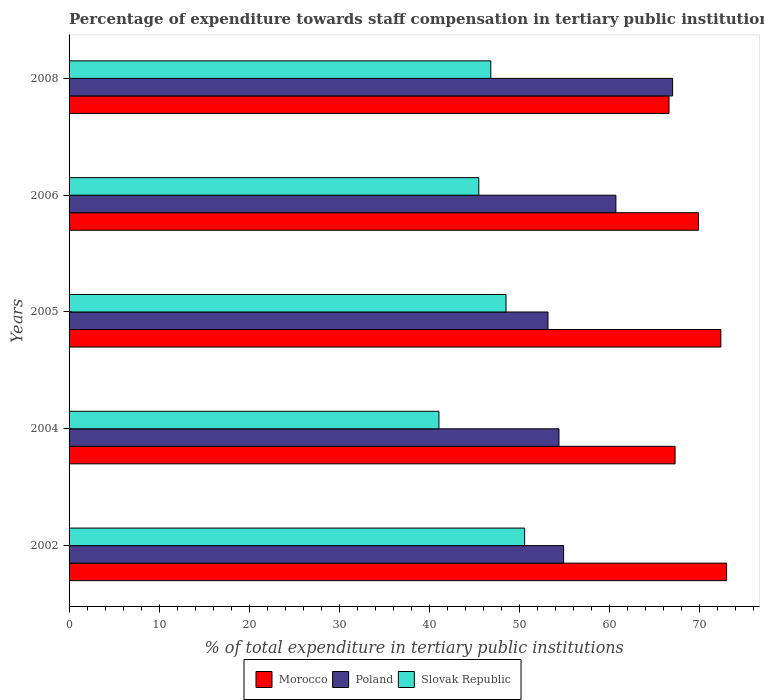How many different coloured bars are there?
Make the answer very short. 3. Are the number of bars per tick equal to the number of legend labels?
Keep it short and to the point. Yes. Are the number of bars on each tick of the Y-axis equal?
Your answer should be very brief. Yes. In how many cases, is the number of bars for a given year not equal to the number of legend labels?
Ensure brevity in your answer.  0. What is the percentage of expenditure towards staff compensation in Poland in 2004?
Your response must be concise. 54.37. Across all years, what is the maximum percentage of expenditure towards staff compensation in Slovak Republic?
Offer a very short reply. 50.56. Across all years, what is the minimum percentage of expenditure towards staff compensation in Poland?
Provide a succinct answer. 53.15. In which year was the percentage of expenditure towards staff compensation in Poland maximum?
Your answer should be compact. 2008. What is the total percentage of expenditure towards staff compensation in Slovak Republic in the graph?
Your answer should be very brief. 232.39. What is the difference between the percentage of expenditure towards staff compensation in Morocco in 2004 and that in 2006?
Your answer should be very brief. -2.59. What is the difference between the percentage of expenditure towards staff compensation in Morocco in 2006 and the percentage of expenditure towards staff compensation in Slovak Republic in 2002?
Provide a short and direct response. 19.29. What is the average percentage of expenditure towards staff compensation in Slovak Republic per year?
Your response must be concise. 46.48. In the year 2002, what is the difference between the percentage of expenditure towards staff compensation in Slovak Republic and percentage of expenditure towards staff compensation in Morocco?
Ensure brevity in your answer.  -22.42. In how many years, is the percentage of expenditure towards staff compensation in Poland greater than 20 %?
Your answer should be compact. 5. What is the ratio of the percentage of expenditure towards staff compensation in Morocco in 2005 to that in 2008?
Offer a terse response. 1.09. What is the difference between the highest and the second highest percentage of expenditure towards staff compensation in Morocco?
Ensure brevity in your answer.  0.64. What is the difference between the highest and the lowest percentage of expenditure towards staff compensation in Poland?
Provide a succinct answer. 13.83. What does the 1st bar from the top in 2002 represents?
Offer a terse response. Slovak Republic. How many years are there in the graph?
Make the answer very short. 5. What is the difference between two consecutive major ticks on the X-axis?
Offer a terse response. 10. Does the graph contain any zero values?
Your answer should be compact. No. Does the graph contain grids?
Keep it short and to the point. No. How are the legend labels stacked?
Your response must be concise. Horizontal. What is the title of the graph?
Keep it short and to the point. Percentage of expenditure towards staff compensation in tertiary public institutions. Does "Kyrgyz Republic" appear as one of the legend labels in the graph?
Offer a very short reply. No. What is the label or title of the X-axis?
Give a very brief answer. % of total expenditure in tertiary public institutions. What is the % of total expenditure in tertiary public institutions of Morocco in 2002?
Ensure brevity in your answer.  72.98. What is the % of total expenditure in tertiary public institutions of Poland in 2002?
Keep it short and to the point. 54.89. What is the % of total expenditure in tertiary public institutions in Slovak Republic in 2002?
Offer a terse response. 50.56. What is the % of total expenditure in tertiary public institutions in Morocco in 2004?
Give a very brief answer. 67.26. What is the % of total expenditure in tertiary public institutions in Poland in 2004?
Your answer should be compact. 54.37. What is the % of total expenditure in tertiary public institutions of Slovak Republic in 2004?
Your answer should be very brief. 41.05. What is the % of total expenditure in tertiary public institutions in Morocco in 2005?
Keep it short and to the point. 72.34. What is the % of total expenditure in tertiary public institutions in Poland in 2005?
Keep it short and to the point. 53.15. What is the % of total expenditure in tertiary public institutions in Slovak Republic in 2005?
Ensure brevity in your answer.  48.5. What is the % of total expenditure in tertiary public institutions of Morocco in 2006?
Your answer should be compact. 69.85. What is the % of total expenditure in tertiary public institutions in Poland in 2006?
Give a very brief answer. 60.69. What is the % of total expenditure in tertiary public institutions in Slovak Republic in 2006?
Your answer should be very brief. 45.47. What is the % of total expenditure in tertiary public institutions in Morocco in 2008?
Keep it short and to the point. 66.59. What is the % of total expenditure in tertiary public institutions of Poland in 2008?
Provide a short and direct response. 66.99. What is the % of total expenditure in tertiary public institutions of Slovak Republic in 2008?
Make the answer very short. 46.81. Across all years, what is the maximum % of total expenditure in tertiary public institutions of Morocco?
Ensure brevity in your answer.  72.98. Across all years, what is the maximum % of total expenditure in tertiary public institutions in Poland?
Provide a short and direct response. 66.99. Across all years, what is the maximum % of total expenditure in tertiary public institutions in Slovak Republic?
Offer a very short reply. 50.56. Across all years, what is the minimum % of total expenditure in tertiary public institutions in Morocco?
Offer a very short reply. 66.59. Across all years, what is the minimum % of total expenditure in tertiary public institutions in Poland?
Make the answer very short. 53.15. Across all years, what is the minimum % of total expenditure in tertiary public institutions of Slovak Republic?
Ensure brevity in your answer.  41.05. What is the total % of total expenditure in tertiary public institutions in Morocco in the graph?
Keep it short and to the point. 349.01. What is the total % of total expenditure in tertiary public institutions in Poland in the graph?
Your answer should be very brief. 290.09. What is the total % of total expenditure in tertiary public institutions in Slovak Republic in the graph?
Your answer should be very brief. 232.39. What is the difference between the % of total expenditure in tertiary public institutions in Morocco in 2002 and that in 2004?
Offer a very short reply. 5.72. What is the difference between the % of total expenditure in tertiary public institutions of Poland in 2002 and that in 2004?
Keep it short and to the point. 0.51. What is the difference between the % of total expenditure in tertiary public institutions of Slovak Republic in 2002 and that in 2004?
Provide a succinct answer. 9.51. What is the difference between the % of total expenditure in tertiary public institutions of Morocco in 2002 and that in 2005?
Offer a terse response. 0.64. What is the difference between the % of total expenditure in tertiary public institutions in Poland in 2002 and that in 2005?
Your answer should be very brief. 1.73. What is the difference between the % of total expenditure in tertiary public institutions of Slovak Republic in 2002 and that in 2005?
Your answer should be compact. 2.06. What is the difference between the % of total expenditure in tertiary public institutions of Morocco in 2002 and that in 2006?
Offer a very short reply. 3.13. What is the difference between the % of total expenditure in tertiary public institutions of Poland in 2002 and that in 2006?
Your answer should be compact. -5.8. What is the difference between the % of total expenditure in tertiary public institutions in Slovak Republic in 2002 and that in 2006?
Your response must be concise. 5.09. What is the difference between the % of total expenditure in tertiary public institutions of Morocco in 2002 and that in 2008?
Offer a very short reply. 6.39. What is the difference between the % of total expenditure in tertiary public institutions of Poland in 2002 and that in 2008?
Provide a succinct answer. -12.1. What is the difference between the % of total expenditure in tertiary public institutions in Slovak Republic in 2002 and that in 2008?
Provide a succinct answer. 3.75. What is the difference between the % of total expenditure in tertiary public institutions in Morocco in 2004 and that in 2005?
Your response must be concise. -5.08. What is the difference between the % of total expenditure in tertiary public institutions in Poland in 2004 and that in 2005?
Your answer should be very brief. 1.22. What is the difference between the % of total expenditure in tertiary public institutions of Slovak Republic in 2004 and that in 2005?
Your response must be concise. -7.45. What is the difference between the % of total expenditure in tertiary public institutions in Morocco in 2004 and that in 2006?
Your answer should be very brief. -2.59. What is the difference between the % of total expenditure in tertiary public institutions in Poland in 2004 and that in 2006?
Offer a very short reply. -6.32. What is the difference between the % of total expenditure in tertiary public institutions of Slovak Republic in 2004 and that in 2006?
Your answer should be very brief. -4.42. What is the difference between the % of total expenditure in tertiary public institutions of Morocco in 2004 and that in 2008?
Make the answer very short. 0.67. What is the difference between the % of total expenditure in tertiary public institutions in Poland in 2004 and that in 2008?
Offer a very short reply. -12.61. What is the difference between the % of total expenditure in tertiary public institutions of Slovak Republic in 2004 and that in 2008?
Give a very brief answer. -5.76. What is the difference between the % of total expenditure in tertiary public institutions in Morocco in 2005 and that in 2006?
Provide a succinct answer. 2.49. What is the difference between the % of total expenditure in tertiary public institutions in Poland in 2005 and that in 2006?
Give a very brief answer. -7.54. What is the difference between the % of total expenditure in tertiary public institutions of Slovak Republic in 2005 and that in 2006?
Provide a short and direct response. 3.02. What is the difference between the % of total expenditure in tertiary public institutions in Morocco in 2005 and that in 2008?
Your answer should be very brief. 5.75. What is the difference between the % of total expenditure in tertiary public institutions in Poland in 2005 and that in 2008?
Your response must be concise. -13.83. What is the difference between the % of total expenditure in tertiary public institutions of Slovak Republic in 2005 and that in 2008?
Ensure brevity in your answer.  1.69. What is the difference between the % of total expenditure in tertiary public institutions of Morocco in 2006 and that in 2008?
Offer a very short reply. 3.27. What is the difference between the % of total expenditure in tertiary public institutions in Poland in 2006 and that in 2008?
Ensure brevity in your answer.  -6.3. What is the difference between the % of total expenditure in tertiary public institutions of Slovak Republic in 2006 and that in 2008?
Keep it short and to the point. -1.33. What is the difference between the % of total expenditure in tertiary public institutions of Morocco in 2002 and the % of total expenditure in tertiary public institutions of Poland in 2004?
Ensure brevity in your answer.  18.61. What is the difference between the % of total expenditure in tertiary public institutions in Morocco in 2002 and the % of total expenditure in tertiary public institutions in Slovak Republic in 2004?
Your answer should be very brief. 31.93. What is the difference between the % of total expenditure in tertiary public institutions in Poland in 2002 and the % of total expenditure in tertiary public institutions in Slovak Republic in 2004?
Make the answer very short. 13.84. What is the difference between the % of total expenditure in tertiary public institutions in Morocco in 2002 and the % of total expenditure in tertiary public institutions in Poland in 2005?
Your answer should be very brief. 19.83. What is the difference between the % of total expenditure in tertiary public institutions of Morocco in 2002 and the % of total expenditure in tertiary public institutions of Slovak Republic in 2005?
Provide a succinct answer. 24.48. What is the difference between the % of total expenditure in tertiary public institutions in Poland in 2002 and the % of total expenditure in tertiary public institutions in Slovak Republic in 2005?
Give a very brief answer. 6.39. What is the difference between the % of total expenditure in tertiary public institutions in Morocco in 2002 and the % of total expenditure in tertiary public institutions in Poland in 2006?
Your answer should be compact. 12.29. What is the difference between the % of total expenditure in tertiary public institutions in Morocco in 2002 and the % of total expenditure in tertiary public institutions in Slovak Republic in 2006?
Your answer should be very brief. 27.5. What is the difference between the % of total expenditure in tertiary public institutions of Poland in 2002 and the % of total expenditure in tertiary public institutions of Slovak Republic in 2006?
Offer a terse response. 9.41. What is the difference between the % of total expenditure in tertiary public institutions of Morocco in 2002 and the % of total expenditure in tertiary public institutions of Poland in 2008?
Offer a terse response. 5.99. What is the difference between the % of total expenditure in tertiary public institutions of Morocco in 2002 and the % of total expenditure in tertiary public institutions of Slovak Republic in 2008?
Make the answer very short. 26.17. What is the difference between the % of total expenditure in tertiary public institutions in Poland in 2002 and the % of total expenditure in tertiary public institutions in Slovak Republic in 2008?
Your answer should be compact. 8.08. What is the difference between the % of total expenditure in tertiary public institutions in Morocco in 2004 and the % of total expenditure in tertiary public institutions in Poland in 2005?
Make the answer very short. 14.11. What is the difference between the % of total expenditure in tertiary public institutions of Morocco in 2004 and the % of total expenditure in tertiary public institutions of Slovak Republic in 2005?
Keep it short and to the point. 18.76. What is the difference between the % of total expenditure in tertiary public institutions of Poland in 2004 and the % of total expenditure in tertiary public institutions of Slovak Republic in 2005?
Make the answer very short. 5.88. What is the difference between the % of total expenditure in tertiary public institutions of Morocco in 2004 and the % of total expenditure in tertiary public institutions of Poland in 2006?
Your answer should be compact. 6.57. What is the difference between the % of total expenditure in tertiary public institutions in Morocco in 2004 and the % of total expenditure in tertiary public institutions in Slovak Republic in 2006?
Give a very brief answer. 21.79. What is the difference between the % of total expenditure in tertiary public institutions in Poland in 2004 and the % of total expenditure in tertiary public institutions in Slovak Republic in 2006?
Offer a terse response. 8.9. What is the difference between the % of total expenditure in tertiary public institutions in Morocco in 2004 and the % of total expenditure in tertiary public institutions in Poland in 2008?
Your answer should be very brief. 0.27. What is the difference between the % of total expenditure in tertiary public institutions in Morocco in 2004 and the % of total expenditure in tertiary public institutions in Slovak Republic in 2008?
Ensure brevity in your answer.  20.45. What is the difference between the % of total expenditure in tertiary public institutions in Poland in 2004 and the % of total expenditure in tertiary public institutions in Slovak Republic in 2008?
Offer a terse response. 7.57. What is the difference between the % of total expenditure in tertiary public institutions in Morocco in 2005 and the % of total expenditure in tertiary public institutions in Poland in 2006?
Keep it short and to the point. 11.65. What is the difference between the % of total expenditure in tertiary public institutions of Morocco in 2005 and the % of total expenditure in tertiary public institutions of Slovak Republic in 2006?
Offer a terse response. 26.86. What is the difference between the % of total expenditure in tertiary public institutions of Poland in 2005 and the % of total expenditure in tertiary public institutions of Slovak Republic in 2006?
Offer a very short reply. 7.68. What is the difference between the % of total expenditure in tertiary public institutions of Morocco in 2005 and the % of total expenditure in tertiary public institutions of Poland in 2008?
Offer a very short reply. 5.35. What is the difference between the % of total expenditure in tertiary public institutions of Morocco in 2005 and the % of total expenditure in tertiary public institutions of Slovak Republic in 2008?
Keep it short and to the point. 25.53. What is the difference between the % of total expenditure in tertiary public institutions in Poland in 2005 and the % of total expenditure in tertiary public institutions in Slovak Republic in 2008?
Your answer should be very brief. 6.35. What is the difference between the % of total expenditure in tertiary public institutions of Morocco in 2006 and the % of total expenditure in tertiary public institutions of Poland in 2008?
Offer a terse response. 2.87. What is the difference between the % of total expenditure in tertiary public institutions of Morocco in 2006 and the % of total expenditure in tertiary public institutions of Slovak Republic in 2008?
Make the answer very short. 23.05. What is the difference between the % of total expenditure in tertiary public institutions in Poland in 2006 and the % of total expenditure in tertiary public institutions in Slovak Republic in 2008?
Your response must be concise. 13.88. What is the average % of total expenditure in tertiary public institutions in Morocco per year?
Give a very brief answer. 69.8. What is the average % of total expenditure in tertiary public institutions of Poland per year?
Give a very brief answer. 58.02. What is the average % of total expenditure in tertiary public institutions in Slovak Republic per year?
Keep it short and to the point. 46.48. In the year 2002, what is the difference between the % of total expenditure in tertiary public institutions of Morocco and % of total expenditure in tertiary public institutions of Poland?
Your answer should be compact. 18.09. In the year 2002, what is the difference between the % of total expenditure in tertiary public institutions in Morocco and % of total expenditure in tertiary public institutions in Slovak Republic?
Offer a very short reply. 22.42. In the year 2002, what is the difference between the % of total expenditure in tertiary public institutions in Poland and % of total expenditure in tertiary public institutions in Slovak Republic?
Provide a short and direct response. 4.33. In the year 2004, what is the difference between the % of total expenditure in tertiary public institutions of Morocco and % of total expenditure in tertiary public institutions of Poland?
Make the answer very short. 12.89. In the year 2004, what is the difference between the % of total expenditure in tertiary public institutions of Morocco and % of total expenditure in tertiary public institutions of Slovak Republic?
Give a very brief answer. 26.21. In the year 2004, what is the difference between the % of total expenditure in tertiary public institutions of Poland and % of total expenditure in tertiary public institutions of Slovak Republic?
Provide a succinct answer. 13.32. In the year 2005, what is the difference between the % of total expenditure in tertiary public institutions of Morocco and % of total expenditure in tertiary public institutions of Poland?
Your answer should be very brief. 19.19. In the year 2005, what is the difference between the % of total expenditure in tertiary public institutions in Morocco and % of total expenditure in tertiary public institutions in Slovak Republic?
Your answer should be very brief. 23.84. In the year 2005, what is the difference between the % of total expenditure in tertiary public institutions of Poland and % of total expenditure in tertiary public institutions of Slovak Republic?
Keep it short and to the point. 4.66. In the year 2006, what is the difference between the % of total expenditure in tertiary public institutions of Morocco and % of total expenditure in tertiary public institutions of Poland?
Offer a very short reply. 9.16. In the year 2006, what is the difference between the % of total expenditure in tertiary public institutions in Morocco and % of total expenditure in tertiary public institutions in Slovak Republic?
Ensure brevity in your answer.  24.38. In the year 2006, what is the difference between the % of total expenditure in tertiary public institutions in Poland and % of total expenditure in tertiary public institutions in Slovak Republic?
Offer a very short reply. 15.22. In the year 2008, what is the difference between the % of total expenditure in tertiary public institutions in Morocco and % of total expenditure in tertiary public institutions in Poland?
Make the answer very short. -0.4. In the year 2008, what is the difference between the % of total expenditure in tertiary public institutions in Morocco and % of total expenditure in tertiary public institutions in Slovak Republic?
Keep it short and to the point. 19.78. In the year 2008, what is the difference between the % of total expenditure in tertiary public institutions in Poland and % of total expenditure in tertiary public institutions in Slovak Republic?
Offer a very short reply. 20.18. What is the ratio of the % of total expenditure in tertiary public institutions in Morocco in 2002 to that in 2004?
Offer a very short reply. 1.08. What is the ratio of the % of total expenditure in tertiary public institutions of Poland in 2002 to that in 2004?
Provide a short and direct response. 1.01. What is the ratio of the % of total expenditure in tertiary public institutions of Slovak Republic in 2002 to that in 2004?
Offer a terse response. 1.23. What is the ratio of the % of total expenditure in tertiary public institutions of Morocco in 2002 to that in 2005?
Your answer should be compact. 1.01. What is the ratio of the % of total expenditure in tertiary public institutions of Poland in 2002 to that in 2005?
Keep it short and to the point. 1.03. What is the ratio of the % of total expenditure in tertiary public institutions of Slovak Republic in 2002 to that in 2005?
Offer a terse response. 1.04. What is the ratio of the % of total expenditure in tertiary public institutions of Morocco in 2002 to that in 2006?
Your response must be concise. 1.04. What is the ratio of the % of total expenditure in tertiary public institutions of Poland in 2002 to that in 2006?
Your answer should be very brief. 0.9. What is the ratio of the % of total expenditure in tertiary public institutions of Slovak Republic in 2002 to that in 2006?
Make the answer very short. 1.11. What is the ratio of the % of total expenditure in tertiary public institutions of Morocco in 2002 to that in 2008?
Make the answer very short. 1.1. What is the ratio of the % of total expenditure in tertiary public institutions in Poland in 2002 to that in 2008?
Provide a succinct answer. 0.82. What is the ratio of the % of total expenditure in tertiary public institutions of Slovak Republic in 2002 to that in 2008?
Your answer should be very brief. 1.08. What is the ratio of the % of total expenditure in tertiary public institutions of Morocco in 2004 to that in 2005?
Give a very brief answer. 0.93. What is the ratio of the % of total expenditure in tertiary public institutions of Poland in 2004 to that in 2005?
Your answer should be very brief. 1.02. What is the ratio of the % of total expenditure in tertiary public institutions of Slovak Republic in 2004 to that in 2005?
Provide a short and direct response. 0.85. What is the ratio of the % of total expenditure in tertiary public institutions of Morocco in 2004 to that in 2006?
Give a very brief answer. 0.96. What is the ratio of the % of total expenditure in tertiary public institutions of Poland in 2004 to that in 2006?
Offer a terse response. 0.9. What is the ratio of the % of total expenditure in tertiary public institutions in Slovak Republic in 2004 to that in 2006?
Ensure brevity in your answer.  0.9. What is the ratio of the % of total expenditure in tertiary public institutions in Poland in 2004 to that in 2008?
Your answer should be compact. 0.81. What is the ratio of the % of total expenditure in tertiary public institutions in Slovak Republic in 2004 to that in 2008?
Offer a very short reply. 0.88. What is the ratio of the % of total expenditure in tertiary public institutions in Morocco in 2005 to that in 2006?
Ensure brevity in your answer.  1.04. What is the ratio of the % of total expenditure in tertiary public institutions in Poland in 2005 to that in 2006?
Keep it short and to the point. 0.88. What is the ratio of the % of total expenditure in tertiary public institutions of Slovak Republic in 2005 to that in 2006?
Offer a terse response. 1.07. What is the ratio of the % of total expenditure in tertiary public institutions of Morocco in 2005 to that in 2008?
Give a very brief answer. 1.09. What is the ratio of the % of total expenditure in tertiary public institutions in Poland in 2005 to that in 2008?
Your answer should be compact. 0.79. What is the ratio of the % of total expenditure in tertiary public institutions of Slovak Republic in 2005 to that in 2008?
Offer a terse response. 1.04. What is the ratio of the % of total expenditure in tertiary public institutions of Morocco in 2006 to that in 2008?
Keep it short and to the point. 1.05. What is the ratio of the % of total expenditure in tertiary public institutions in Poland in 2006 to that in 2008?
Make the answer very short. 0.91. What is the ratio of the % of total expenditure in tertiary public institutions of Slovak Republic in 2006 to that in 2008?
Provide a short and direct response. 0.97. What is the difference between the highest and the second highest % of total expenditure in tertiary public institutions of Morocco?
Give a very brief answer. 0.64. What is the difference between the highest and the second highest % of total expenditure in tertiary public institutions of Poland?
Make the answer very short. 6.3. What is the difference between the highest and the second highest % of total expenditure in tertiary public institutions of Slovak Republic?
Make the answer very short. 2.06. What is the difference between the highest and the lowest % of total expenditure in tertiary public institutions of Morocco?
Provide a short and direct response. 6.39. What is the difference between the highest and the lowest % of total expenditure in tertiary public institutions in Poland?
Keep it short and to the point. 13.83. What is the difference between the highest and the lowest % of total expenditure in tertiary public institutions in Slovak Republic?
Make the answer very short. 9.51. 